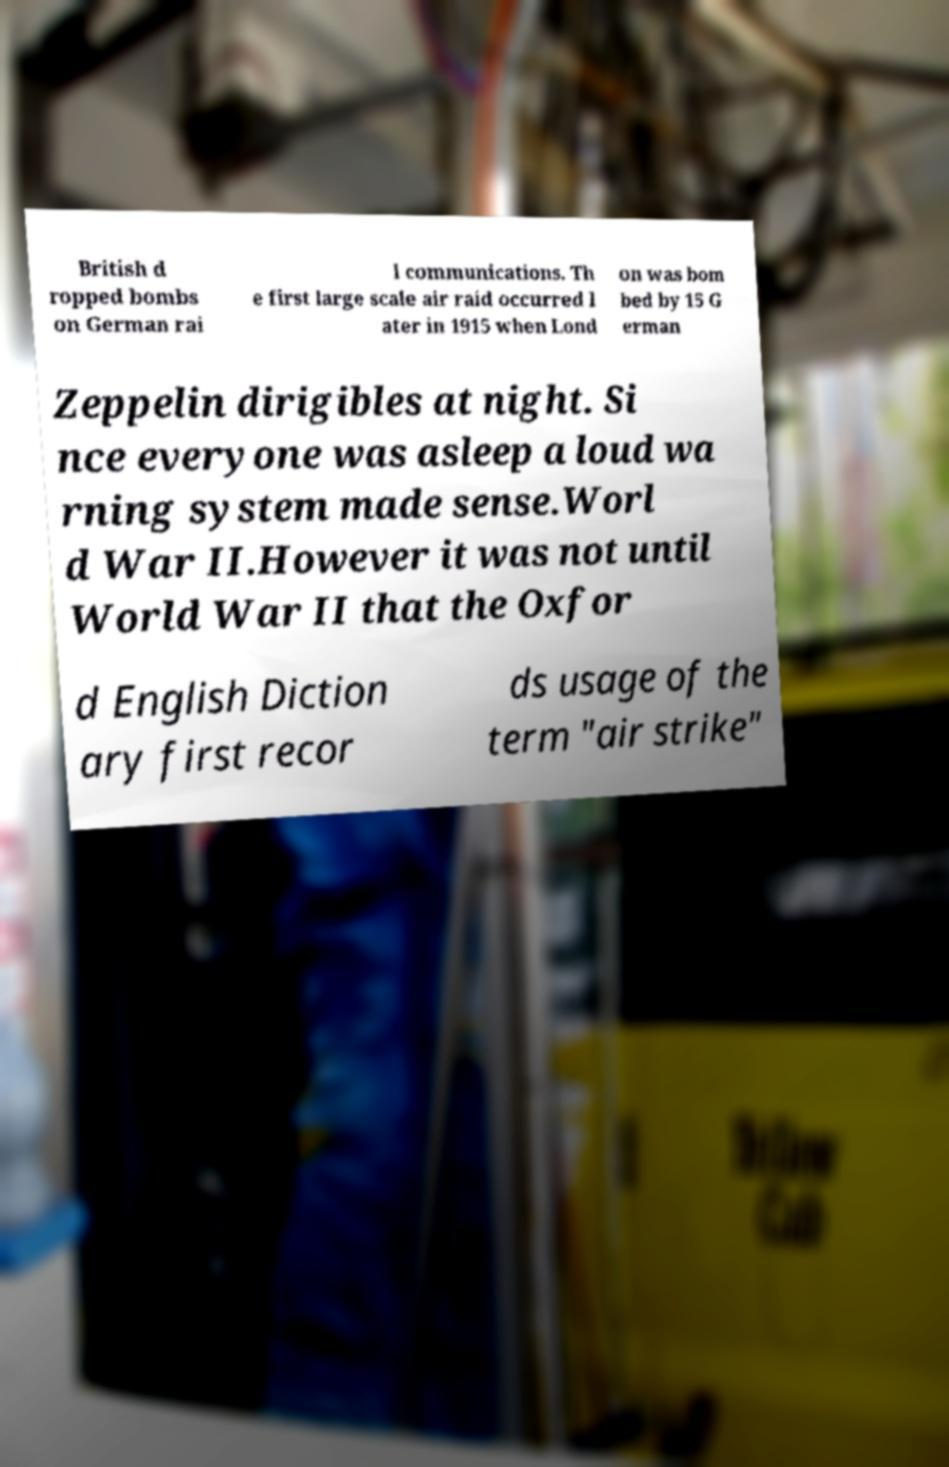I need the written content from this picture converted into text. Can you do that? British d ropped bombs on German rai l communications. Th e first large scale air raid occurred l ater in 1915 when Lond on was bom bed by 15 G erman Zeppelin dirigibles at night. Si nce everyone was asleep a loud wa rning system made sense.Worl d War II.However it was not until World War II that the Oxfor d English Diction ary first recor ds usage of the term "air strike" 